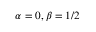Convert formula to latex. <formula><loc_0><loc_0><loc_500><loc_500>\alpha = 0 , \beta = 1 / 2</formula> 